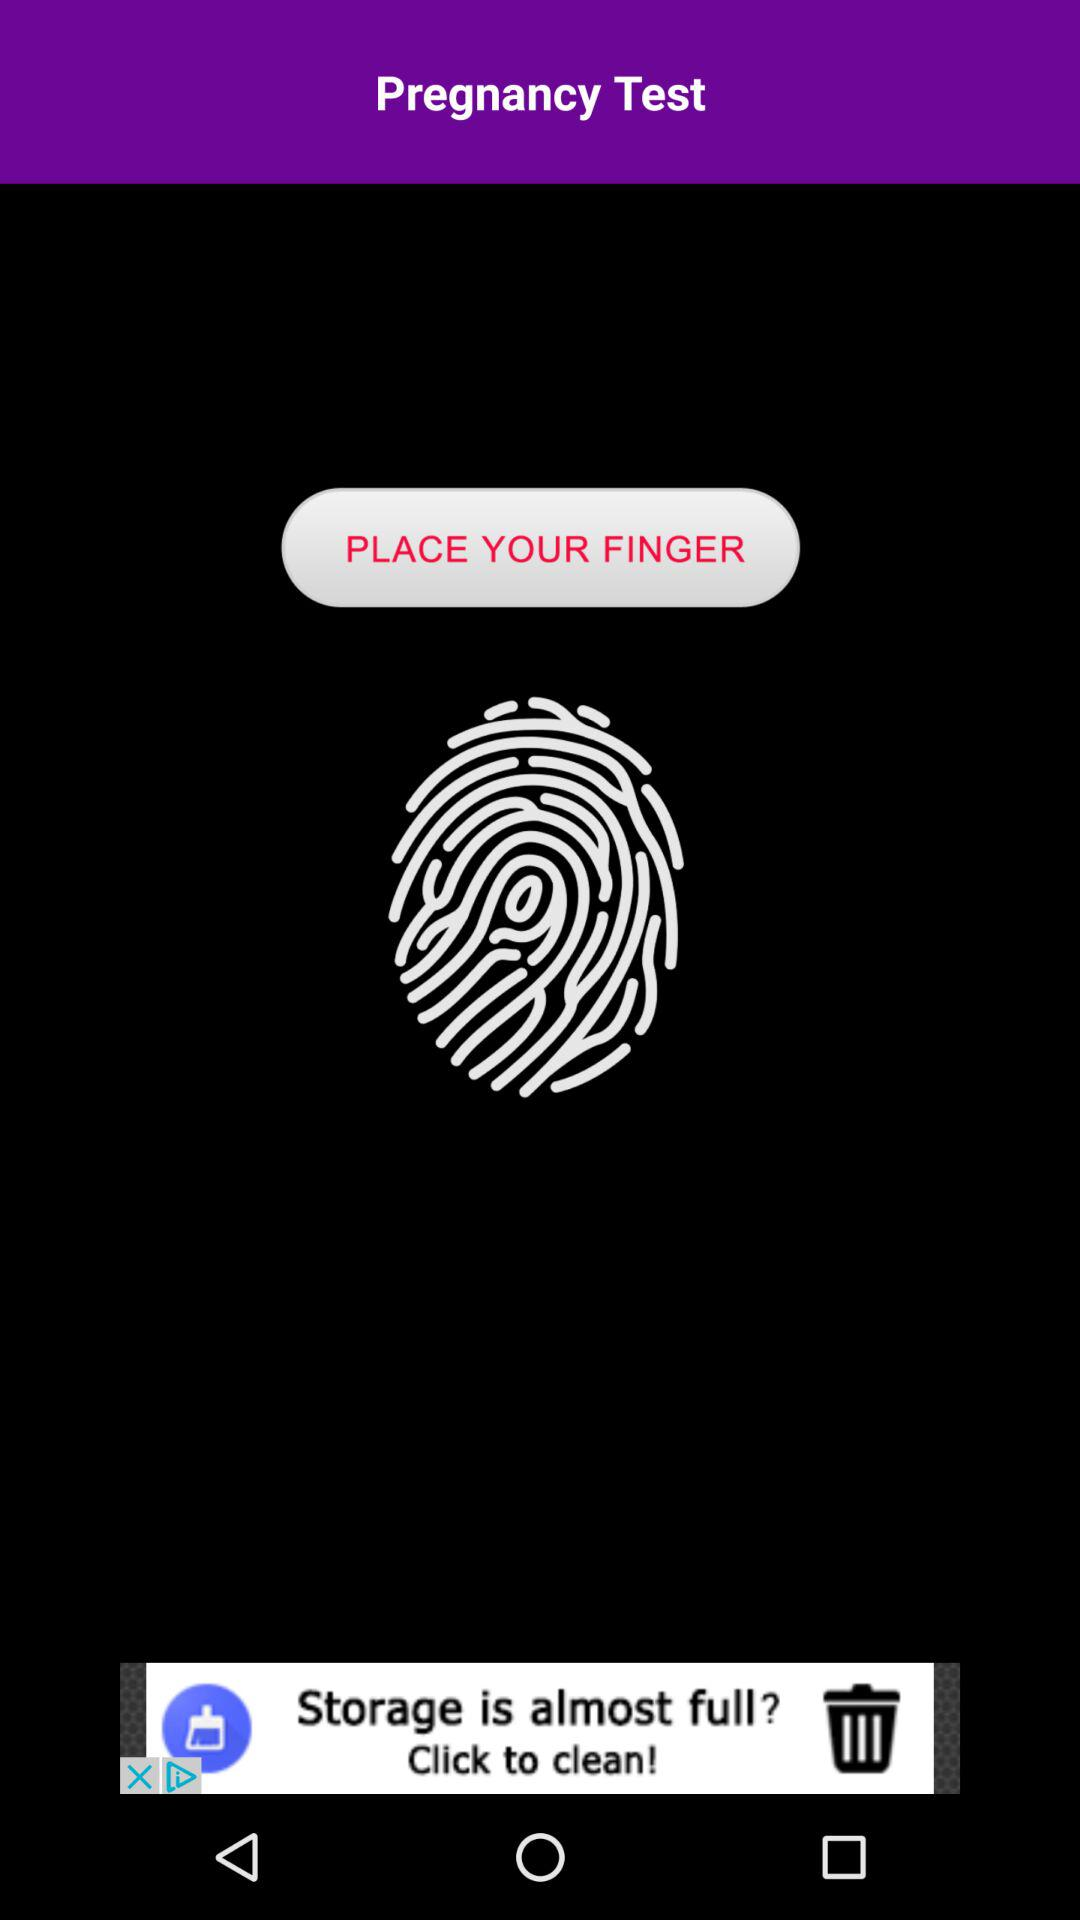What is the application name? The application name is "Pregnancy Test". 